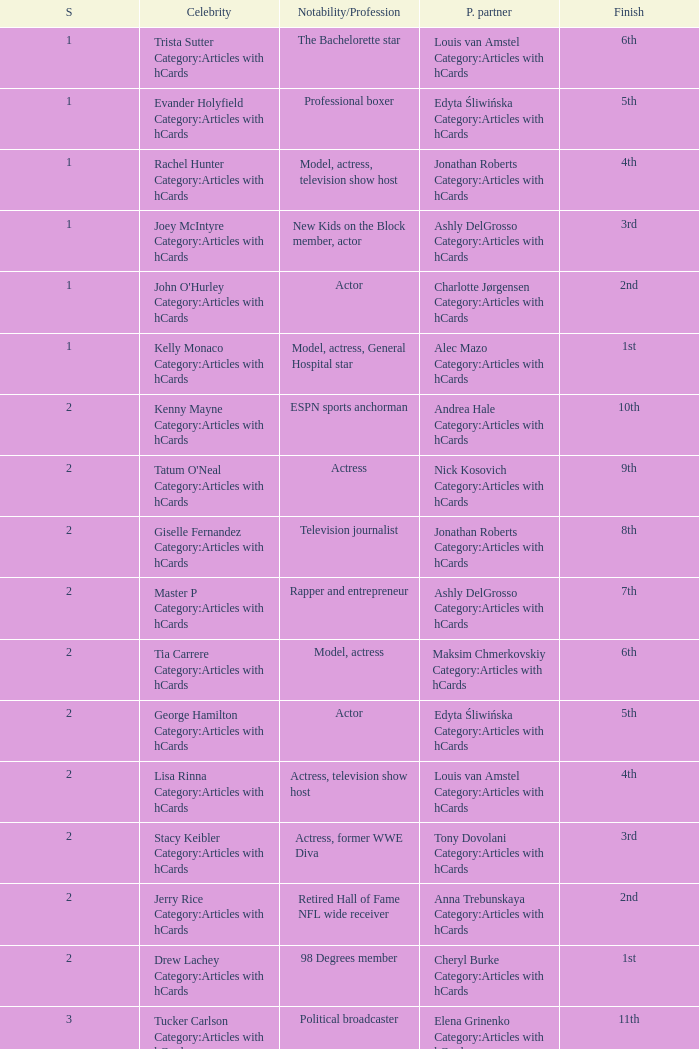What was the profession of the celebrity who was featured on season 15 and finished 7th place? Actress, comedian. 